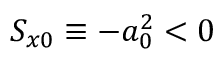Convert formula to latex. <formula><loc_0><loc_0><loc_500><loc_500>S _ { x 0 } \equiv - a _ { 0 } ^ { 2 } < 0</formula> 